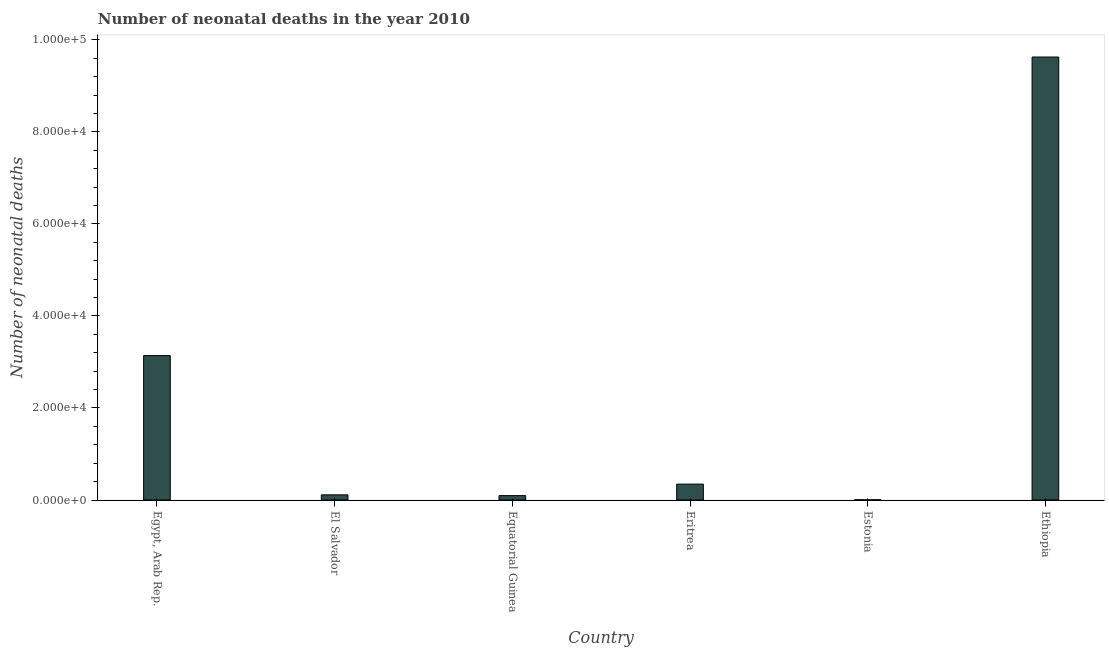Does the graph contain any zero values?
Provide a succinct answer. No. Does the graph contain grids?
Offer a terse response. No. What is the title of the graph?
Your answer should be very brief. Number of neonatal deaths in the year 2010. What is the label or title of the Y-axis?
Provide a succinct answer. Number of neonatal deaths. What is the number of neonatal deaths in Egypt, Arab Rep.?
Provide a short and direct response. 3.14e+04. Across all countries, what is the maximum number of neonatal deaths?
Your response must be concise. 9.63e+04. Across all countries, what is the minimum number of neonatal deaths?
Give a very brief answer. 41. In which country was the number of neonatal deaths maximum?
Make the answer very short. Ethiopia. In which country was the number of neonatal deaths minimum?
Your answer should be very brief. Estonia. What is the sum of the number of neonatal deaths?
Keep it short and to the point. 1.33e+05. What is the difference between the number of neonatal deaths in Egypt, Arab Rep. and Eritrea?
Offer a very short reply. 2.79e+04. What is the average number of neonatal deaths per country?
Your answer should be compact. 2.22e+04. What is the median number of neonatal deaths?
Provide a short and direct response. 2286.5. In how many countries, is the number of neonatal deaths greater than 84000 ?
Your answer should be compact. 1. What is the difference between the highest and the second highest number of neonatal deaths?
Ensure brevity in your answer.  6.49e+04. Is the sum of the number of neonatal deaths in Equatorial Guinea and Ethiopia greater than the maximum number of neonatal deaths across all countries?
Ensure brevity in your answer.  Yes. What is the difference between the highest and the lowest number of neonatal deaths?
Offer a terse response. 9.62e+04. How many bars are there?
Your answer should be compact. 6. Are all the bars in the graph horizontal?
Offer a very short reply. No. How many countries are there in the graph?
Make the answer very short. 6. Are the values on the major ticks of Y-axis written in scientific E-notation?
Make the answer very short. Yes. What is the Number of neonatal deaths in Egypt, Arab Rep.?
Your answer should be very brief. 3.14e+04. What is the Number of neonatal deaths in El Salvador?
Offer a terse response. 1122. What is the Number of neonatal deaths in Equatorial Guinea?
Your response must be concise. 950. What is the Number of neonatal deaths of Eritrea?
Ensure brevity in your answer.  3451. What is the Number of neonatal deaths of Ethiopia?
Provide a short and direct response. 9.63e+04. What is the difference between the Number of neonatal deaths in Egypt, Arab Rep. and El Salvador?
Make the answer very short. 3.03e+04. What is the difference between the Number of neonatal deaths in Egypt, Arab Rep. and Equatorial Guinea?
Give a very brief answer. 3.04e+04. What is the difference between the Number of neonatal deaths in Egypt, Arab Rep. and Eritrea?
Provide a short and direct response. 2.79e+04. What is the difference between the Number of neonatal deaths in Egypt, Arab Rep. and Estonia?
Your answer should be compact. 3.13e+04. What is the difference between the Number of neonatal deaths in Egypt, Arab Rep. and Ethiopia?
Offer a very short reply. -6.49e+04. What is the difference between the Number of neonatal deaths in El Salvador and Equatorial Guinea?
Your response must be concise. 172. What is the difference between the Number of neonatal deaths in El Salvador and Eritrea?
Your answer should be compact. -2329. What is the difference between the Number of neonatal deaths in El Salvador and Estonia?
Provide a short and direct response. 1081. What is the difference between the Number of neonatal deaths in El Salvador and Ethiopia?
Offer a terse response. -9.51e+04. What is the difference between the Number of neonatal deaths in Equatorial Guinea and Eritrea?
Offer a terse response. -2501. What is the difference between the Number of neonatal deaths in Equatorial Guinea and Estonia?
Offer a very short reply. 909. What is the difference between the Number of neonatal deaths in Equatorial Guinea and Ethiopia?
Your answer should be very brief. -9.53e+04. What is the difference between the Number of neonatal deaths in Eritrea and Estonia?
Offer a terse response. 3410. What is the difference between the Number of neonatal deaths in Eritrea and Ethiopia?
Provide a succinct answer. -9.28e+04. What is the difference between the Number of neonatal deaths in Estonia and Ethiopia?
Offer a very short reply. -9.62e+04. What is the ratio of the Number of neonatal deaths in Egypt, Arab Rep. to that in El Salvador?
Ensure brevity in your answer.  27.97. What is the ratio of the Number of neonatal deaths in Egypt, Arab Rep. to that in Equatorial Guinea?
Offer a very short reply. 33.03. What is the ratio of the Number of neonatal deaths in Egypt, Arab Rep. to that in Eritrea?
Make the answer very short. 9.09. What is the ratio of the Number of neonatal deaths in Egypt, Arab Rep. to that in Estonia?
Your response must be concise. 765.34. What is the ratio of the Number of neonatal deaths in Egypt, Arab Rep. to that in Ethiopia?
Ensure brevity in your answer.  0.33. What is the ratio of the Number of neonatal deaths in El Salvador to that in Equatorial Guinea?
Your answer should be very brief. 1.18. What is the ratio of the Number of neonatal deaths in El Salvador to that in Eritrea?
Give a very brief answer. 0.33. What is the ratio of the Number of neonatal deaths in El Salvador to that in Estonia?
Provide a succinct answer. 27.37. What is the ratio of the Number of neonatal deaths in El Salvador to that in Ethiopia?
Ensure brevity in your answer.  0.01. What is the ratio of the Number of neonatal deaths in Equatorial Guinea to that in Eritrea?
Your response must be concise. 0.28. What is the ratio of the Number of neonatal deaths in Equatorial Guinea to that in Estonia?
Provide a succinct answer. 23.17. What is the ratio of the Number of neonatal deaths in Equatorial Guinea to that in Ethiopia?
Provide a short and direct response. 0.01. What is the ratio of the Number of neonatal deaths in Eritrea to that in Estonia?
Your answer should be very brief. 84.17. What is the ratio of the Number of neonatal deaths in Eritrea to that in Ethiopia?
Your answer should be very brief. 0.04. What is the ratio of the Number of neonatal deaths in Estonia to that in Ethiopia?
Offer a very short reply. 0. 